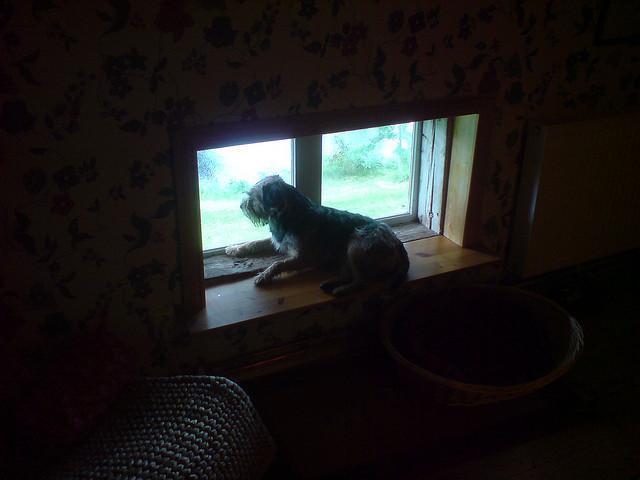How many dogs are in the picture?
Give a very brief answer. 1. How many bowls can be seen?
Give a very brief answer. 1. How many people are shown?
Give a very brief answer. 0. 